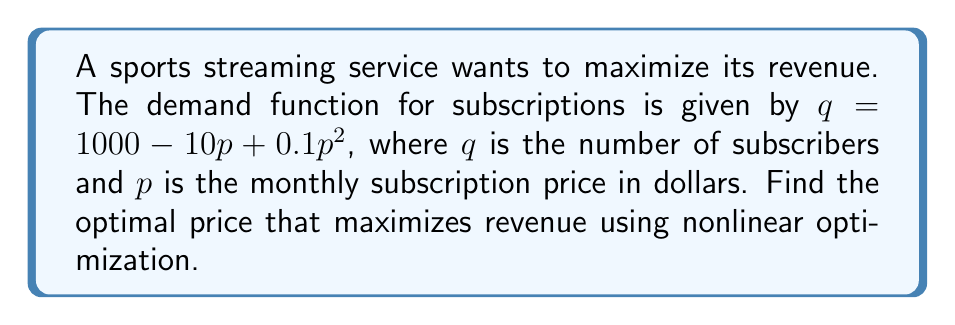Teach me how to tackle this problem. To solve this problem, we'll follow these steps:

1) Revenue is given by price times quantity: $R = pq$

2) Substitute the demand function into the revenue equation:
   $R = p(1000 - 10p + 0.1p^2)$

3) Expand the equation:
   $R = 1000p - 10p^2 + 0.1p^3$

4) To find the maximum revenue, we need to find where the derivative of R with respect to p is zero:
   $$\frac{dR}{dp} = 1000 - 20p + 0.3p^2$$

5) Set this equal to zero:
   $1000 - 20p + 0.3p^2 = 0$

6) Rearrange to standard quadratic form:
   $0.3p^2 - 20p + 1000 = 0$

7) Solve using the quadratic formula: $p = \frac{-b \pm \sqrt{b^2 - 4ac}}{2a}$
   
   $a = 0.3$, $b = -20$, $c = 1000$

   $p = \frac{20 \pm \sqrt{400 - 1200}}{0.6} = \frac{20 \pm \sqrt{-800}}{0.6}$

8) Since we can't have a negative value under the square root, there's only one real solution:
   $p = \frac{20}{0.6} = 33.33$

9) To confirm this is a maximum, we can check the second derivative:
   $$\frac{d^2R}{dp^2} = -20 + 0.6p$$
   At $p = 33.33$, this is negative, confirming a maximum.

Therefore, the optimal price is $33.33 per month.
Answer: $33.33 